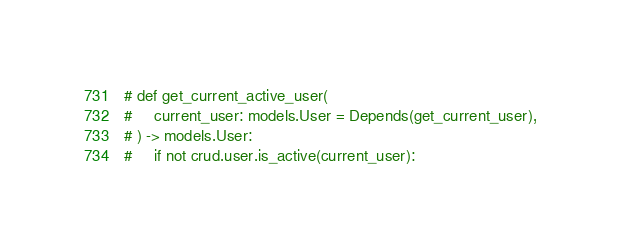Convert code to text. <code><loc_0><loc_0><loc_500><loc_500><_Python_>

# def get_current_active_user(
#     current_user: models.User = Depends(get_current_user),
# ) -> models.User:
#     if not crud.user.is_active(current_user):</code> 